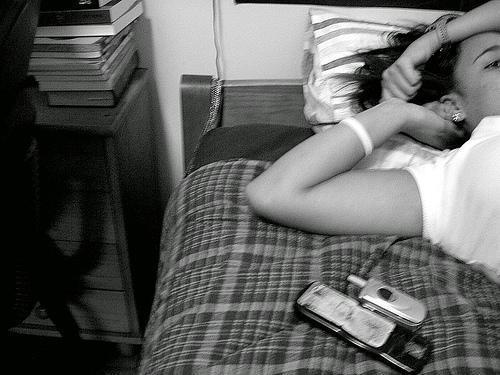How many cell phones are there?
Give a very brief answer. 2. 